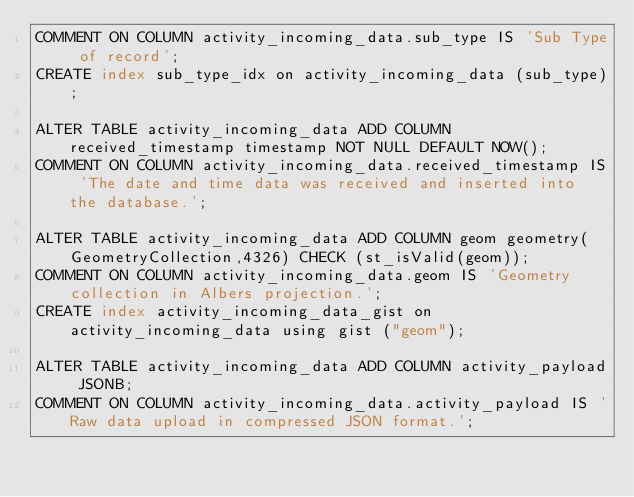Convert code to text. <code><loc_0><loc_0><loc_500><loc_500><_SQL_>COMMENT ON COLUMN activity_incoming_data.sub_type IS 'Sub Type of record';
CREATE index sub_type_idx on activity_incoming_data (sub_type);

ALTER TABLE activity_incoming_data ADD COLUMN received_timestamp timestamp NOT NULL DEFAULT NOW();
COMMENT ON COLUMN activity_incoming_data.received_timestamp IS 'The date and time data was received and inserted into the database.';

ALTER TABLE activity_incoming_data ADD COLUMN geom geometry(GeometryCollection,4326) CHECK (st_isValid(geom));
COMMENT ON COLUMN activity_incoming_data.geom IS 'Geometry collection in Albers projection.';
CREATE index activity_incoming_data_gist on activity_incoming_data using gist ("geom");

ALTER TABLE activity_incoming_data ADD COLUMN activity_payload JSONB;
COMMENT ON COLUMN activity_incoming_data.activity_payload IS 'Raw data upload in compressed JSON format.';

</code> 